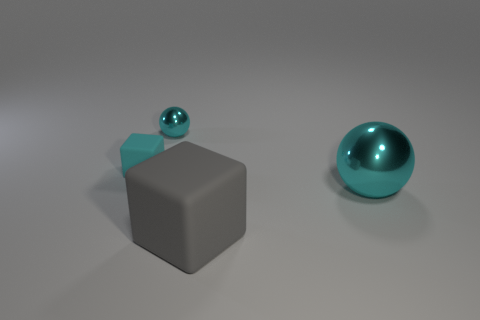There is a ball that is the same size as the cyan block; what is its color?
Offer a terse response. Cyan. Is there a rubber thing that is on the left side of the large matte object that is right of the small cyan shiny object?
Ensure brevity in your answer.  Yes. What material is the sphere that is left of the big gray matte object?
Make the answer very short. Metal. Is the material of the cyan ball to the left of the large cyan metallic ball the same as the big thing behind the big matte object?
Your response must be concise. Yes. Are there an equal number of large gray rubber things that are in front of the big gray rubber object and big gray rubber blocks that are right of the tiny matte cube?
Provide a short and direct response. No. What number of tiny cyan balls are made of the same material as the cyan block?
Provide a succinct answer. 0. There is another shiny object that is the same color as the tiny shiny object; what is its shape?
Offer a very short reply. Sphere. There is a cyan metallic sphere that is behind the rubber thing that is behind the big rubber object; what is its size?
Your answer should be very brief. Small. There is a thing that is on the right side of the gray cube; does it have the same shape as the tiny cyan object in front of the small cyan shiny thing?
Offer a very short reply. No. Is the number of big metallic balls behind the big gray matte cube the same as the number of tiny cyan metal things?
Your response must be concise. Yes. 